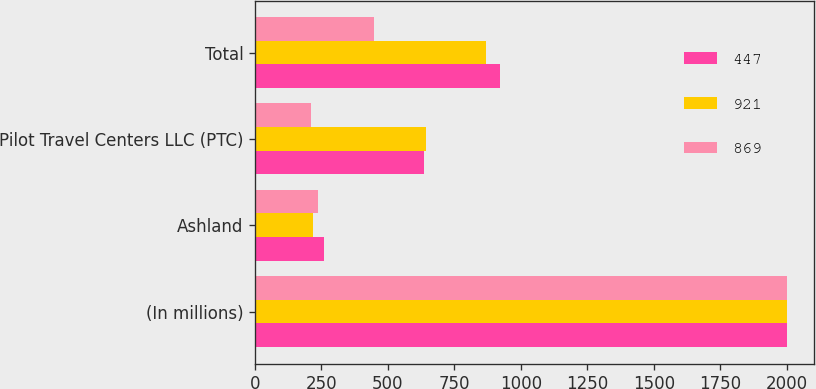<chart> <loc_0><loc_0><loc_500><loc_500><stacked_bar_chart><ecel><fcel>(In millions)<fcel>Ashland<fcel>Pilot Travel Centers LLC (PTC)<fcel>Total<nl><fcel>447<fcel>2003<fcel>258<fcel>635<fcel>921<nl><fcel>921<fcel>2002<fcel>218<fcel>645<fcel>869<nl><fcel>869<fcel>2001<fcel>237<fcel>210<fcel>447<nl></chart> 